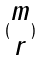Convert formula to latex. <formula><loc_0><loc_0><loc_500><loc_500>( \begin{matrix} m \\ r \end{matrix} )</formula> 